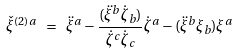Convert formula to latex. <formula><loc_0><loc_0><loc_500><loc_500>\check { \xi } ^ { ( 2 ) a } \ = \ \ddot { \xi } ^ { a } - \frac { ( \ddot { \xi } ^ { b } \dot { \zeta } _ { b } ) } { \dot { \zeta } ^ { c } \dot { \zeta } _ { c } } \dot { \zeta } ^ { a } - ( \ddot { \xi } ^ { b } \xi _ { b } ) \xi ^ { a }</formula> 